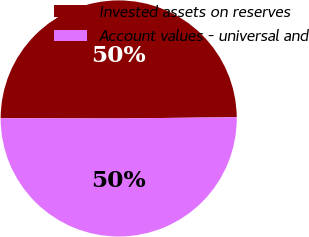Convert chart. <chart><loc_0><loc_0><loc_500><loc_500><pie_chart><fcel>Invested assets on reserves<fcel>Account values - universal and<nl><fcel>49.8%<fcel>50.2%<nl></chart> 